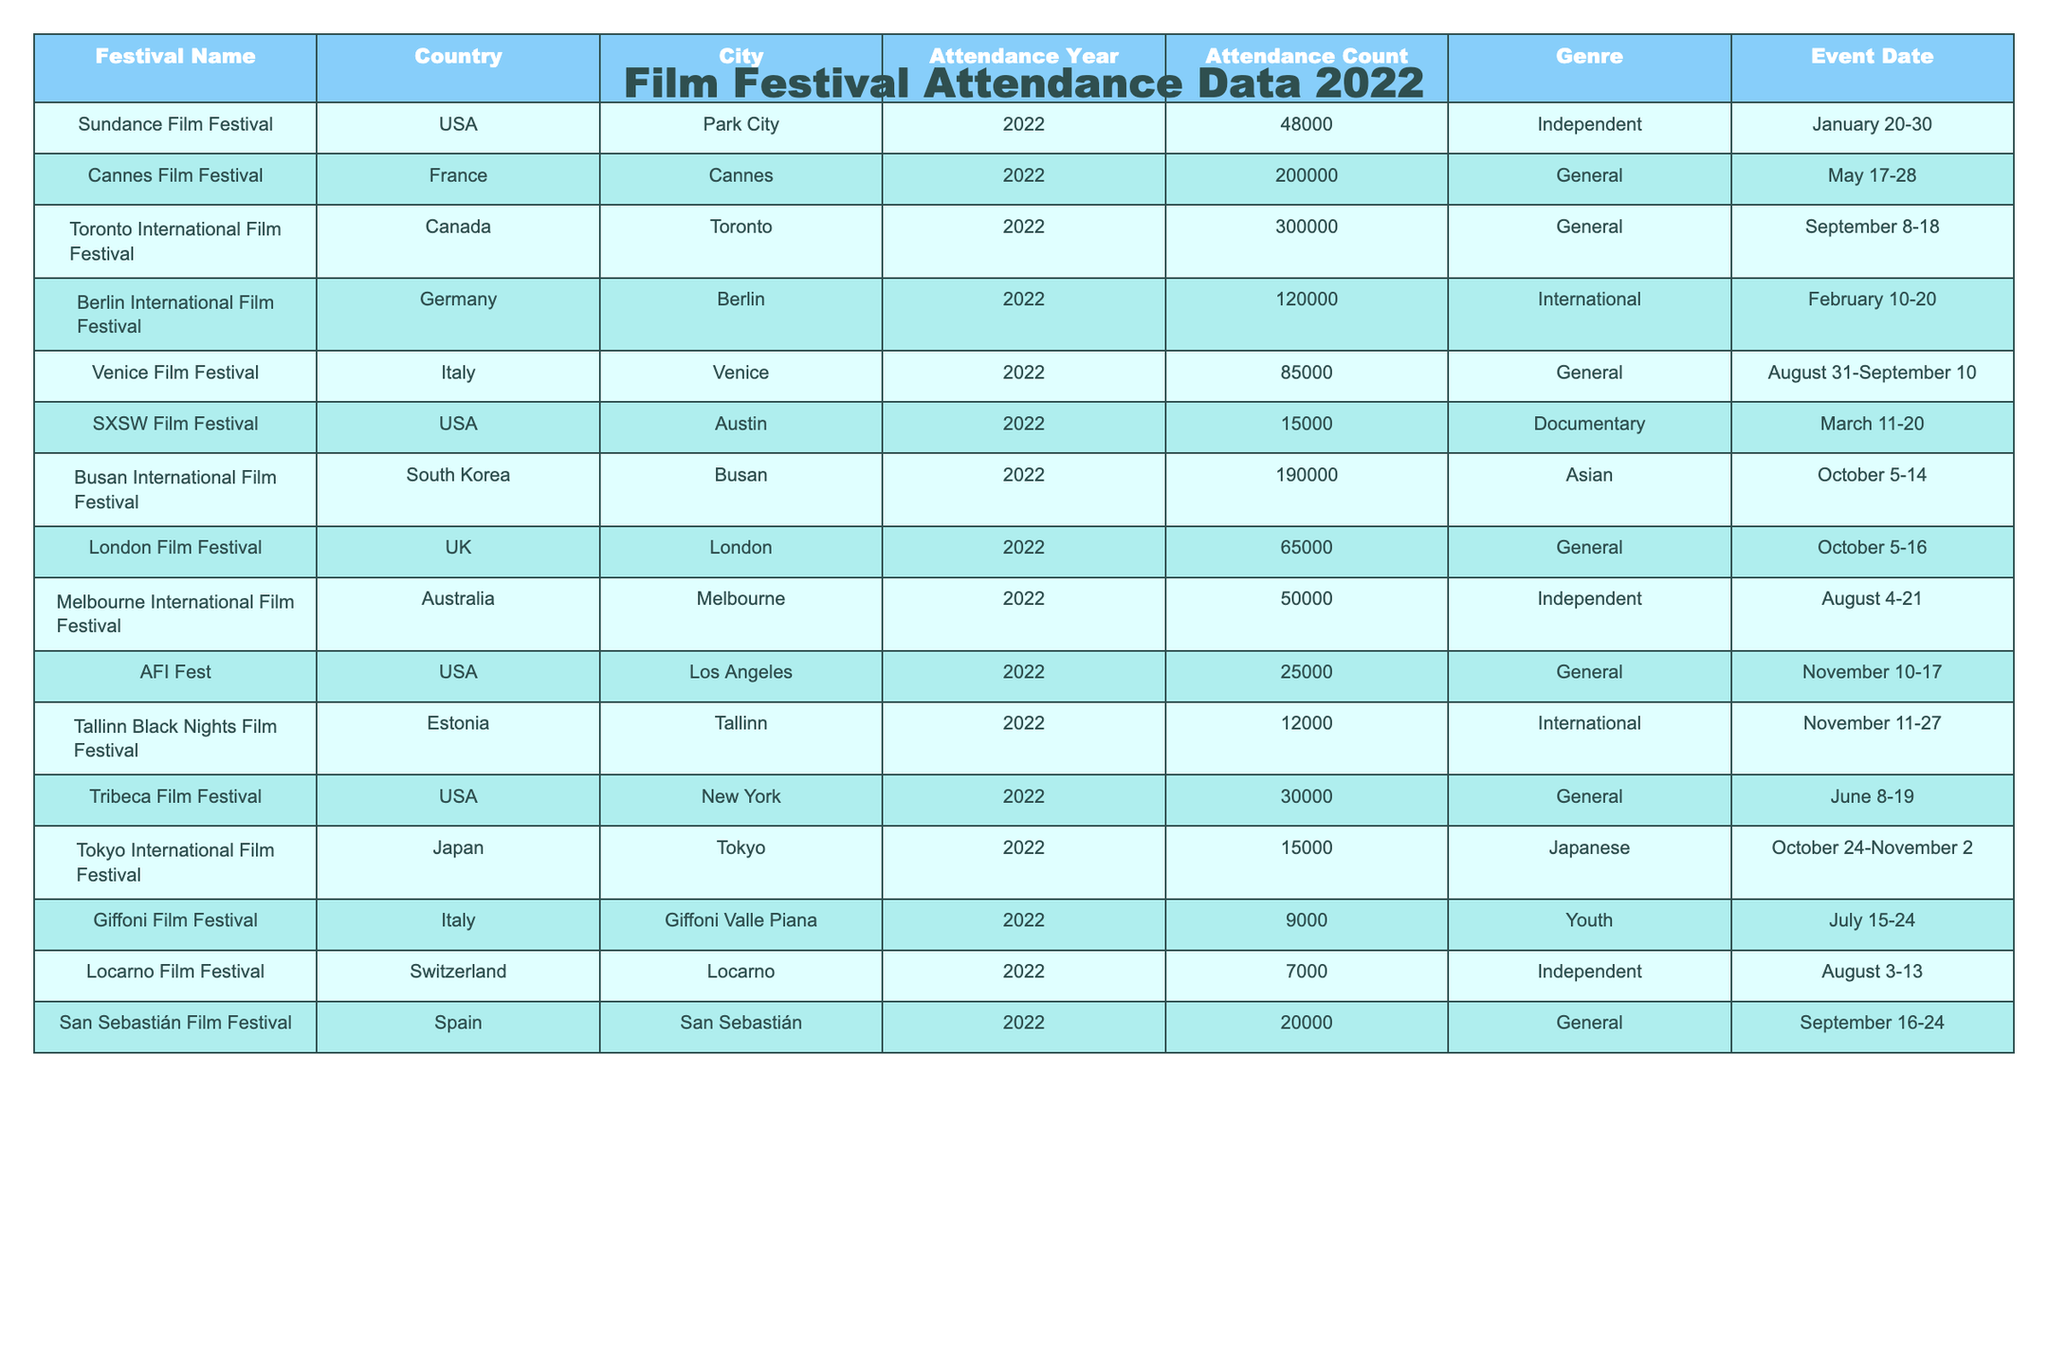What is the attendance count at the Cannes Film Festival? The Cannes Film Festival is recorded in the table with an attendance count specified. By locating the row for the Cannes Film Festival, we see that the attendance count is 200,000.
Answer: 200000 Which film festival had the highest attendance in 2022? To find the highest attendance, we compare the attendance counts from all the festivals. The Toronto International Film Festival has the highest attendance at 300,000.
Answer: 300000 How many festivals had an attendance of more than 100,000? Count the festivals with attendance greater than 100,000 by reviewing each row. The festivals are: Cannes, Busan, and Toronto, which total 3.
Answer: 3 Is the Giffoni Film Festival categorized as a Youth genre? Check the genre listed for the Giffoni Film Festival in the table. The genre is indeed mentioned as "Youth," confirming the statement.
Answer: Yes What is the average attendance for all festivals held in the USA? First, identify the festivals in the USA: Sundance, SXSW, AFI, and Tribeca. Their attendance counts are 48,000, 15,000, 25,000, and 30,000. Adding these gives 118,000, and dividing by 4 (the number of festivals) results in 29,500.
Answer: 29500 Which country hosted the film festival with the lowest attendance? Review the attendance counts for all the festivals and determine which one is the lowest. The Locarno Film Festival has the lowest attendance, recorded at 7,000.
Answer: 7000 Was there any festival with an attendance of 15,000? Search through the table for any festival that matches this attendance count. The SXSW Film Festival and Tokyo International Film Festival both have attendance counts of 15,000, thus the answer is yes.
Answer: Yes What is the difference in attendance between the Berlin and Venice Film Festivals? To find the difference, look up the attendance counts for both festivals: Berlin has 120,000 and Venice has 85,000. The difference is calculated by subtracting 85,000 from 120,000, yielding 35,000.
Answer: 35000 In which month did the Berlin International Film Festival take place? The event date for the Berlin International Film Festival is listed as February 10-20, which indicates it took place in February.
Answer: February If we sum the attendance of Independent genre festivals, what is the total? Identify the festivals that belong to the Independent genre: Sundance and Melbourne. Their attendance counts are 48,000 and 50,000 respectively. Adding these gives 98,000, which is the total attendance for Independent genre festivals.
Answer: 98000 